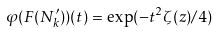<formula> <loc_0><loc_0><loc_500><loc_500>\varphi ( F ( N _ { k } ^ { \prime } ) ) ( t ) = \exp ( - t ^ { 2 } \zeta ( z ) / 4 )</formula> 